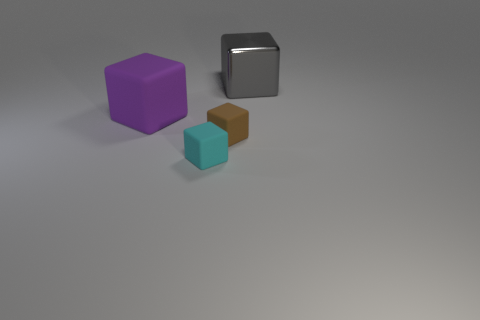Is the number of large rubber things that are in front of the big rubber cube less than the number of metal blocks in front of the large gray thing?
Your answer should be compact. No. The cube that is on the left side of the tiny brown object and behind the small brown object is made of what material?
Make the answer very short. Rubber. Is the shape of the small brown matte object the same as the thing on the left side of the cyan matte object?
Make the answer very short. Yes. How many other objects are there of the same size as the gray metal block?
Your answer should be very brief. 1. Are there more big gray metal things than big yellow rubber cylinders?
Make the answer very short. Yes. How many blocks are in front of the metallic cube and behind the big matte cube?
Your answer should be compact. 0. There is a big thing that is on the right side of the big block that is to the left of the large cube behind the purple matte thing; what shape is it?
Provide a short and direct response. Cube. Is there any other thing that has the same shape as the gray metal thing?
Provide a short and direct response. Yes. How many blocks are either big metal things or purple objects?
Make the answer very short. 2. What material is the big block that is left of the big object on the right side of the matte cube to the right of the cyan block?
Provide a succinct answer. Rubber. 